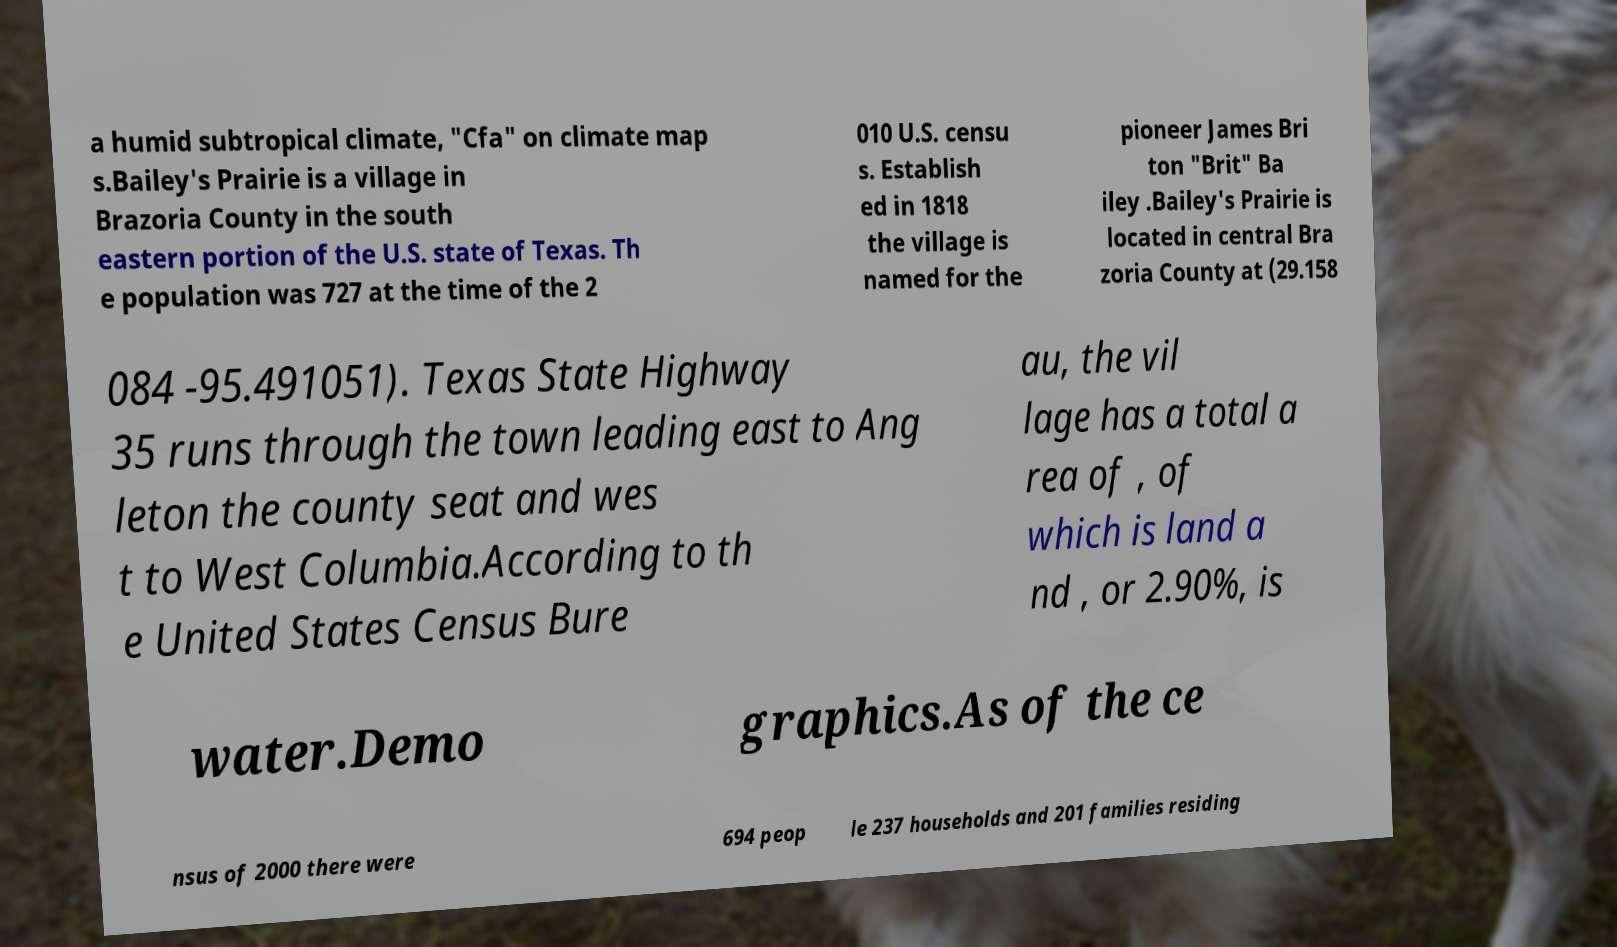Could you extract and type out the text from this image? a humid subtropical climate, "Cfa" on climate map s.Bailey's Prairie is a village in Brazoria County in the south eastern portion of the U.S. state of Texas. Th e population was 727 at the time of the 2 010 U.S. censu s. Establish ed in 1818 the village is named for the pioneer James Bri ton "Brit" Ba iley .Bailey's Prairie is located in central Bra zoria County at (29.158 084 -95.491051). Texas State Highway 35 runs through the town leading east to Ang leton the county seat and wes t to West Columbia.According to th e United States Census Bure au, the vil lage has a total a rea of , of which is land a nd , or 2.90%, is water.Demo graphics.As of the ce nsus of 2000 there were 694 peop le 237 households and 201 families residing 